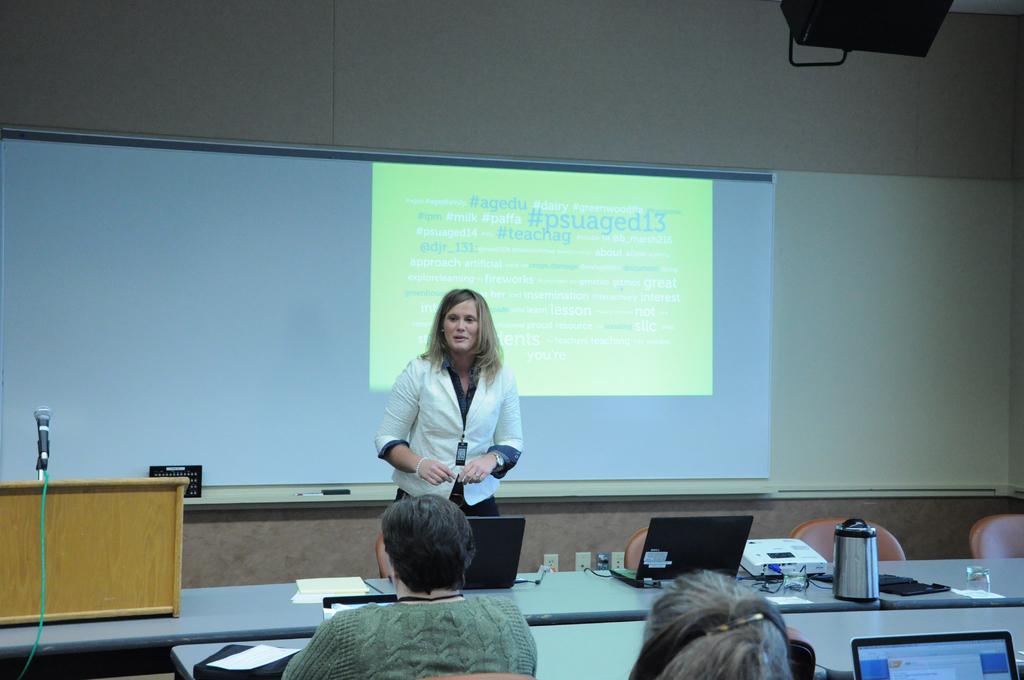In one or two sentences, can you explain what this image depicts? This is an image clicked inside the room. In the middle of the image there is a woman wearing white color suit and standing. At the back of her there is a screen. On the bottom of the image I can see few people are sitting on the chairs In front of the table. On the table I can see monitors and few papers. On the left side of the image I can see a mike fixed to a table. 